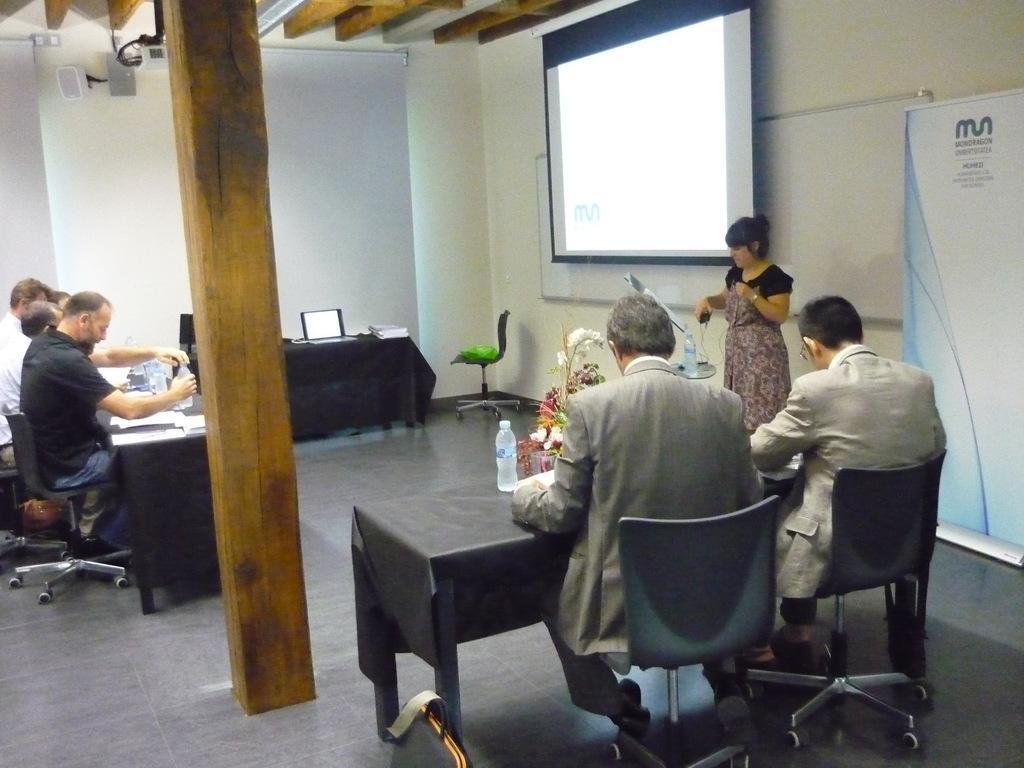Could you give a brief overview of what you see in this image? The image is taken inside a room. On the left side of image there are people sitting on a chair. On the right side there is a screen. There is a chair. There is a bottle, a laptop and books placed on a table. There is a lady who is standing before the screen is presenting. There are two people who are sitting next to her. 